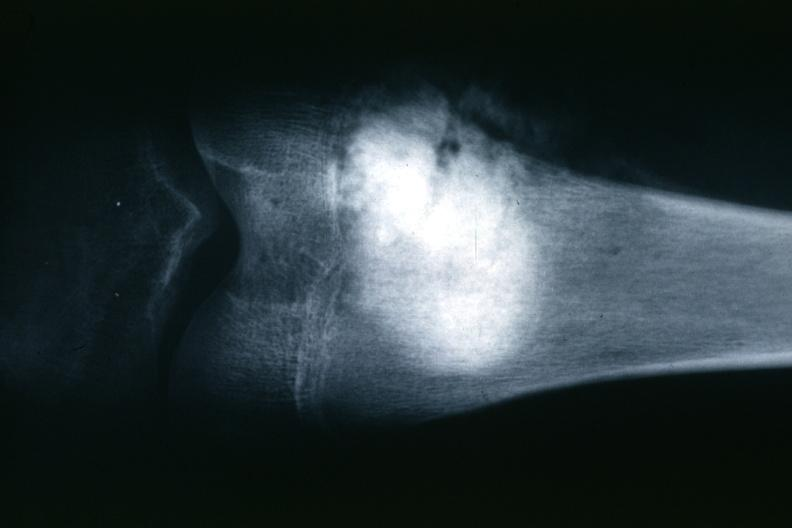what does this image show?
Answer the question using a single word or phrase. X-ray typical lesion 